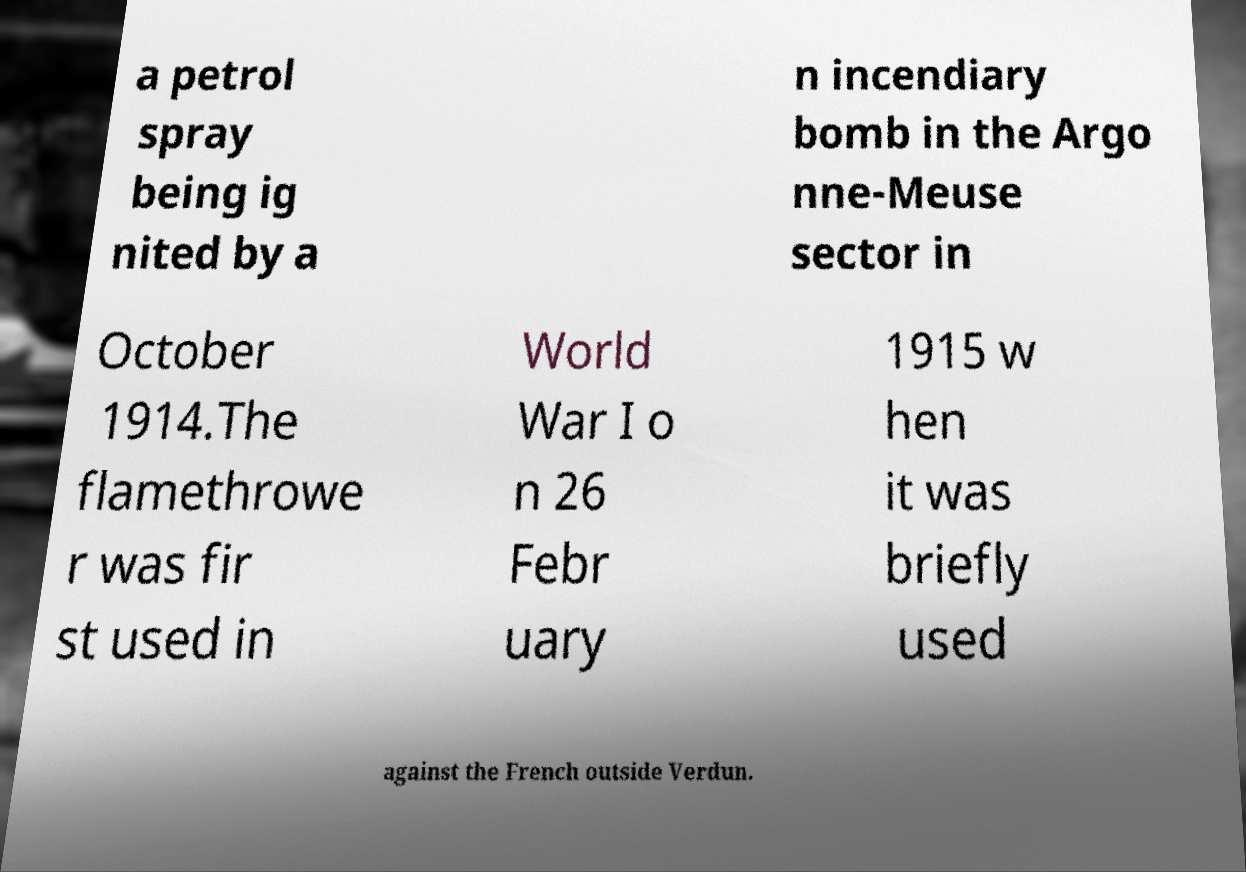There's text embedded in this image that I need extracted. Can you transcribe it verbatim? a petrol spray being ig nited by a n incendiary bomb in the Argo nne-Meuse sector in October 1914.The flamethrowe r was fir st used in World War I o n 26 Febr uary 1915 w hen it was briefly used against the French outside Verdun. 